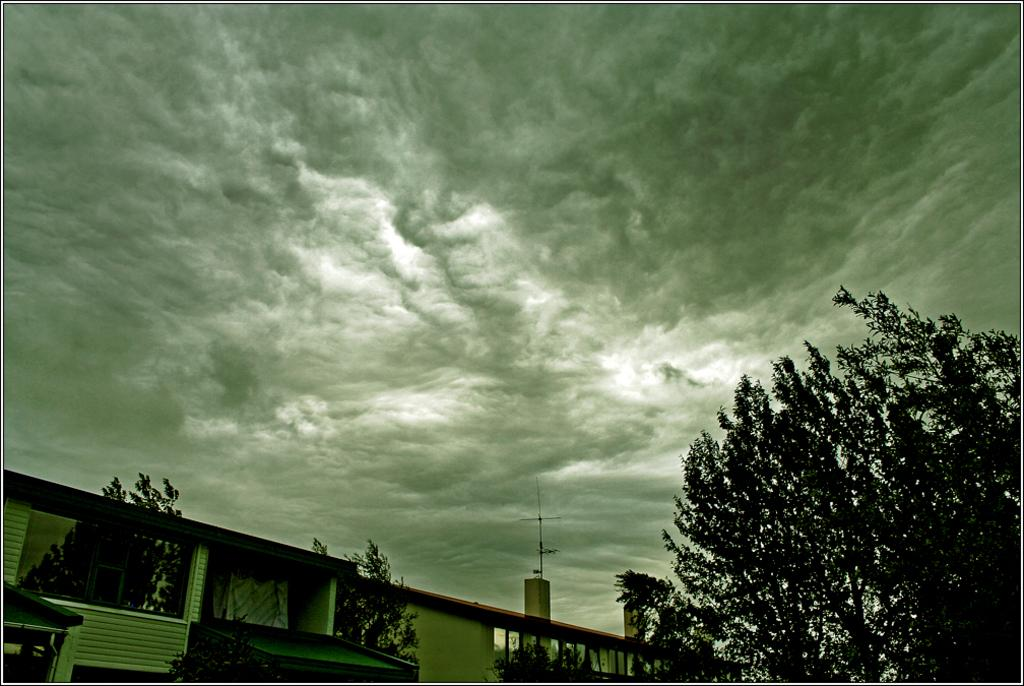What type of structure is present in the image? There is a building in the image. What is located near the building? There is a fence in the image. What type of vegetation can be seen in the image? There are trees in the image. What else can be seen in the image besides the building, fence, and trees? There are other objects in the image. What is visible in the background of the image? The sky is visible in the background of the image. Can you see a kitty pulling the fence in the image? There is no kitty or any indication of pulling in the image. 